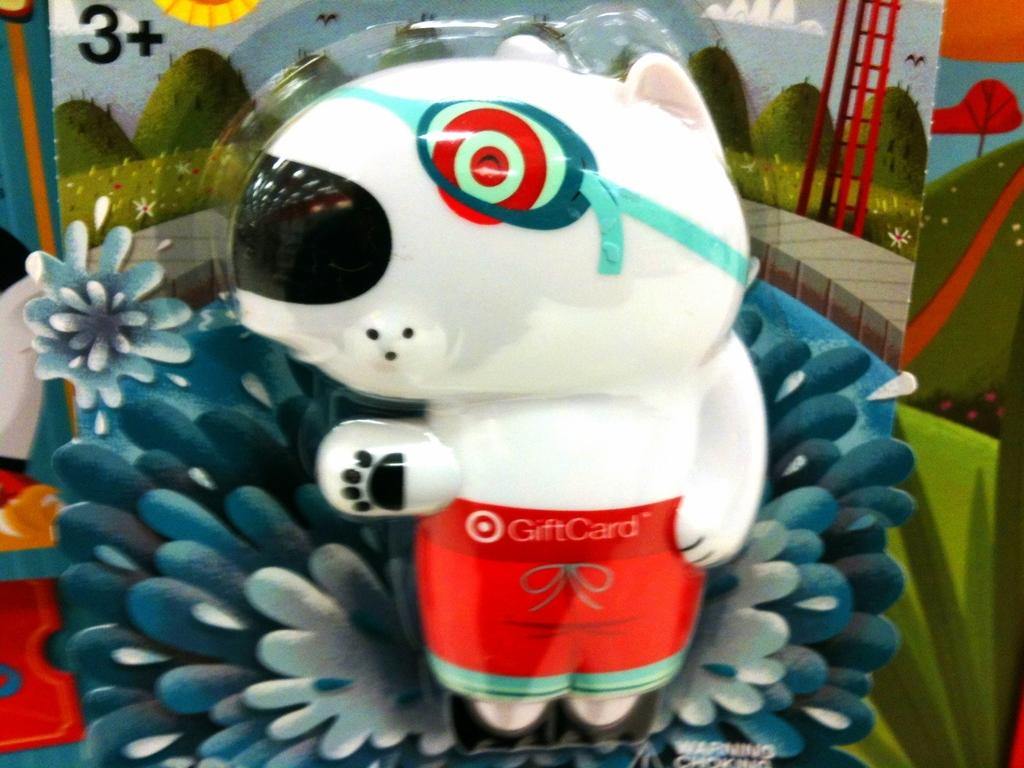What is the color of the toy in the image? The toy in the image is white. What can be found on the toy? The toy has text on it. What is present in the background of the image? There is a board in the background of the image. What can be seen on the board? The board has paintings on it. Can you tell me how many tanks are visible in the image? There are no tanks present in the image. What type of board is being used to push the toy in the image? The toy is not being pushed in the image, and there is no board used for pushing. 